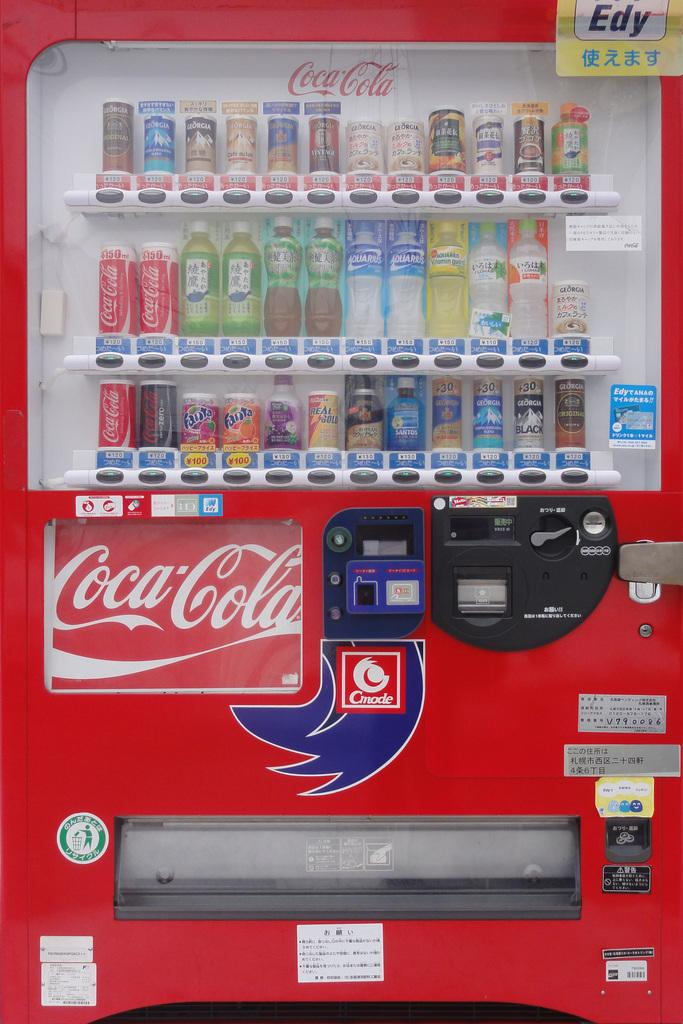<image>
Describe the image concisely. A red Coca-Cola machine with various choices including Fanta and water. 